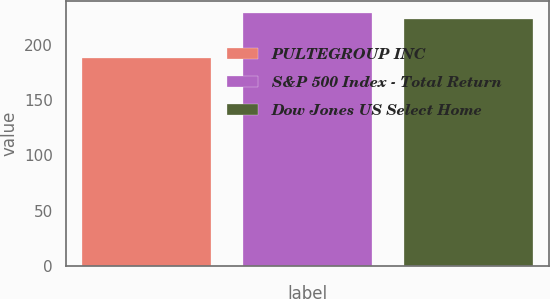Convert chart to OTSL. <chart><loc_0><loc_0><loc_500><loc_500><bar_chart><fcel>PULTEGROUP INC<fcel>S&P 500 Index - Total Return<fcel>Dow Jones US Select Home<nl><fcel>187.99<fcel>228.17<fcel>223.18<nl></chart> 